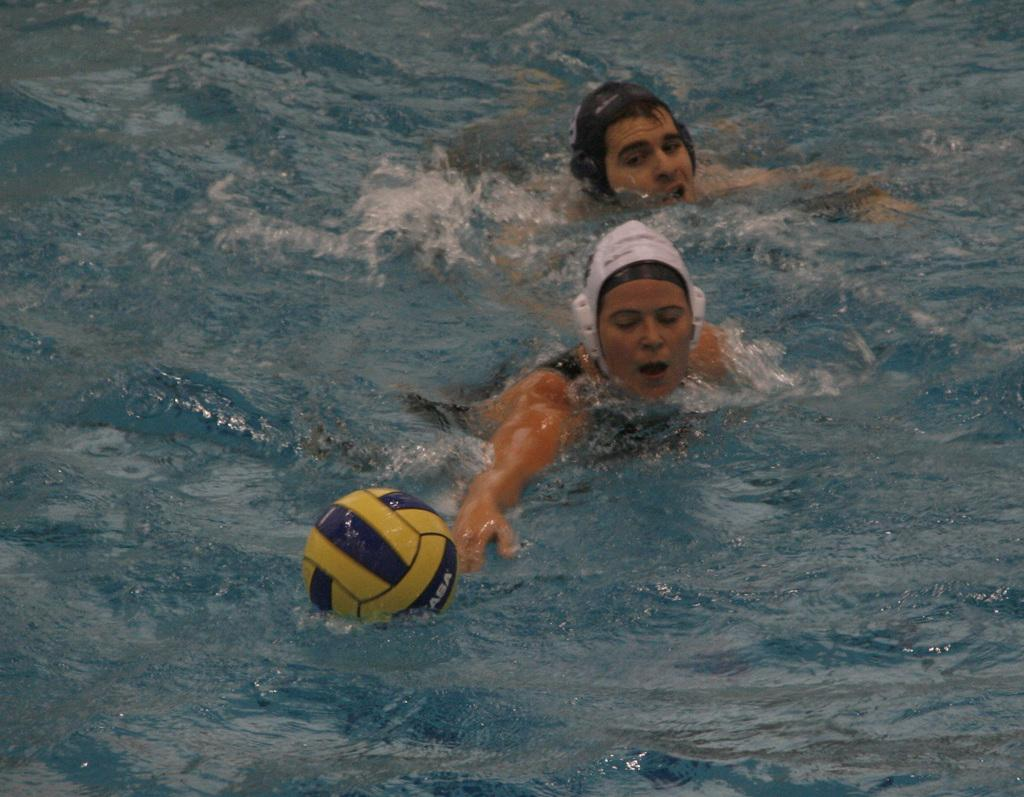How many people are in the image? There are two persons in the image. What is in the water in the image? There is a ball in the water. Can you describe the water in the image? There is water visible in the image, and the background of the image includes water as well. What type of rail can be seen in the image? There is no rail present in the image. Are there any lawyers visible in the image? There are no lawyers present in the image. What kind of animals can be seen at the zoo in the image? There is no zoo present in the image. 